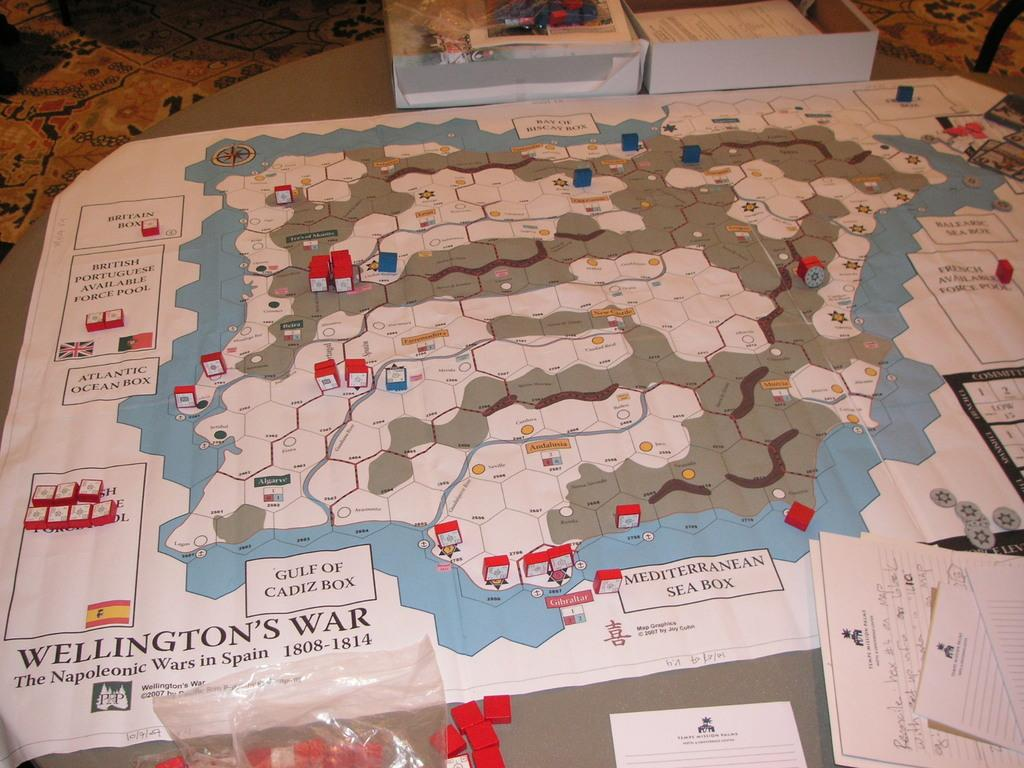Provide a one-sentence caption for the provided image. A strategy map of The Napoleonic Wars in Spain is adorned with red and white markers. 